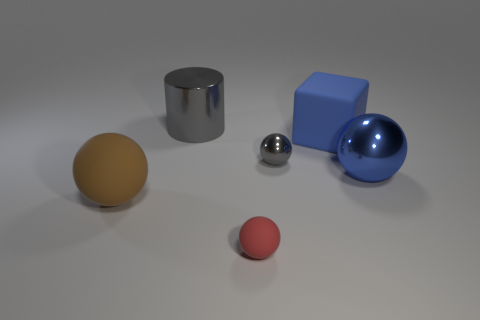Subtract 1 spheres. How many spheres are left? 3 Subtract all blue balls. How many balls are left? 3 Subtract all purple balls. Subtract all green blocks. How many balls are left? 4 Add 3 large blue objects. How many objects exist? 9 Subtract all spheres. How many objects are left? 2 Subtract 0 yellow balls. How many objects are left? 6 Subtract all big blue matte things. Subtract all large metallic balls. How many objects are left? 4 Add 2 blue cubes. How many blue cubes are left? 3 Add 5 large metallic objects. How many large metallic objects exist? 7 